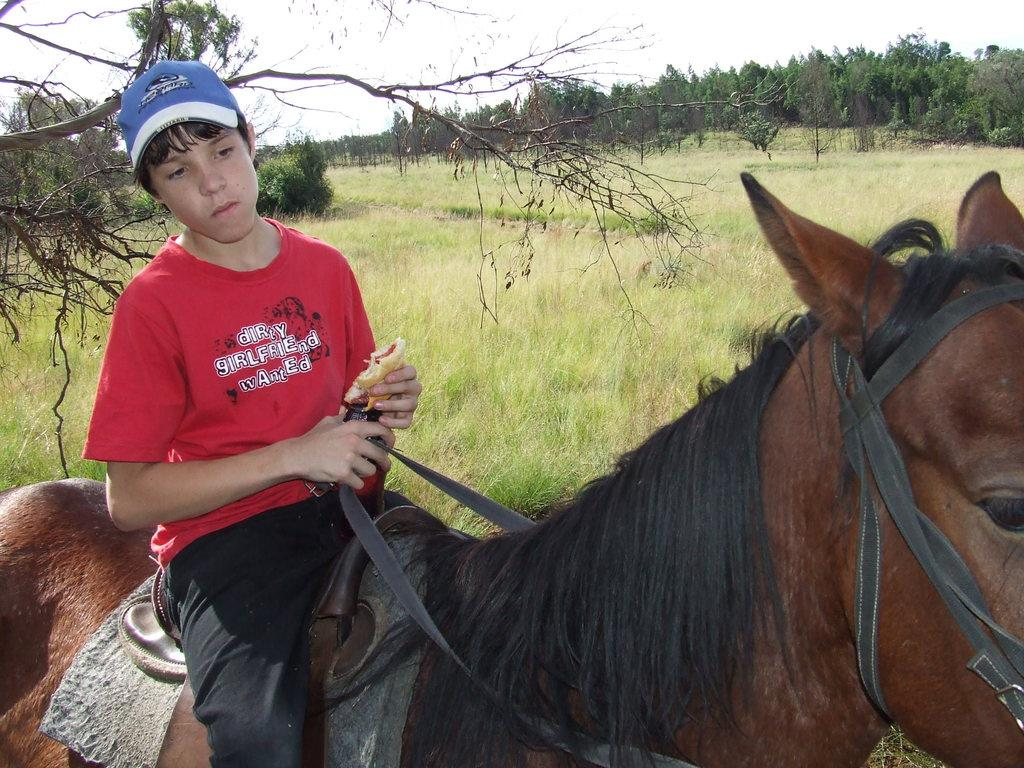Who is the main subject in the image? There is a boy in the image. What is the boy doing in the image? The boy is sitting on a horse and eating a food item. What type of vegetation can be seen in the image? There are trees, plants, and grass in the image. What part of the natural environment is visible in the image? The sky is visible in the image. Where is the sink located in the image? There is no sink present in the image. Can you describe the bed that the boy is lying on in the image? There is no bed present in the image; the boy is sitting on a horse. 